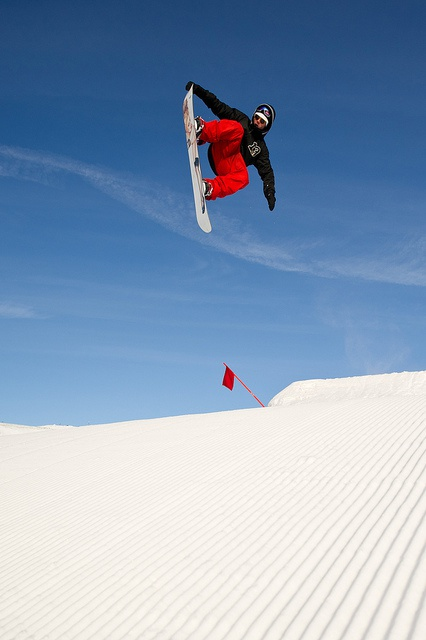Describe the objects in this image and their specific colors. I can see people in darkblue, black, red, and maroon tones and snowboard in darkblue, lightgray, darkgray, gray, and blue tones in this image. 